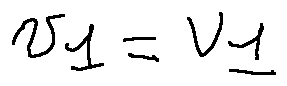<formula> <loc_0><loc_0><loc_500><loc_500>u _ { 1 } = v _ { 1 }</formula> 